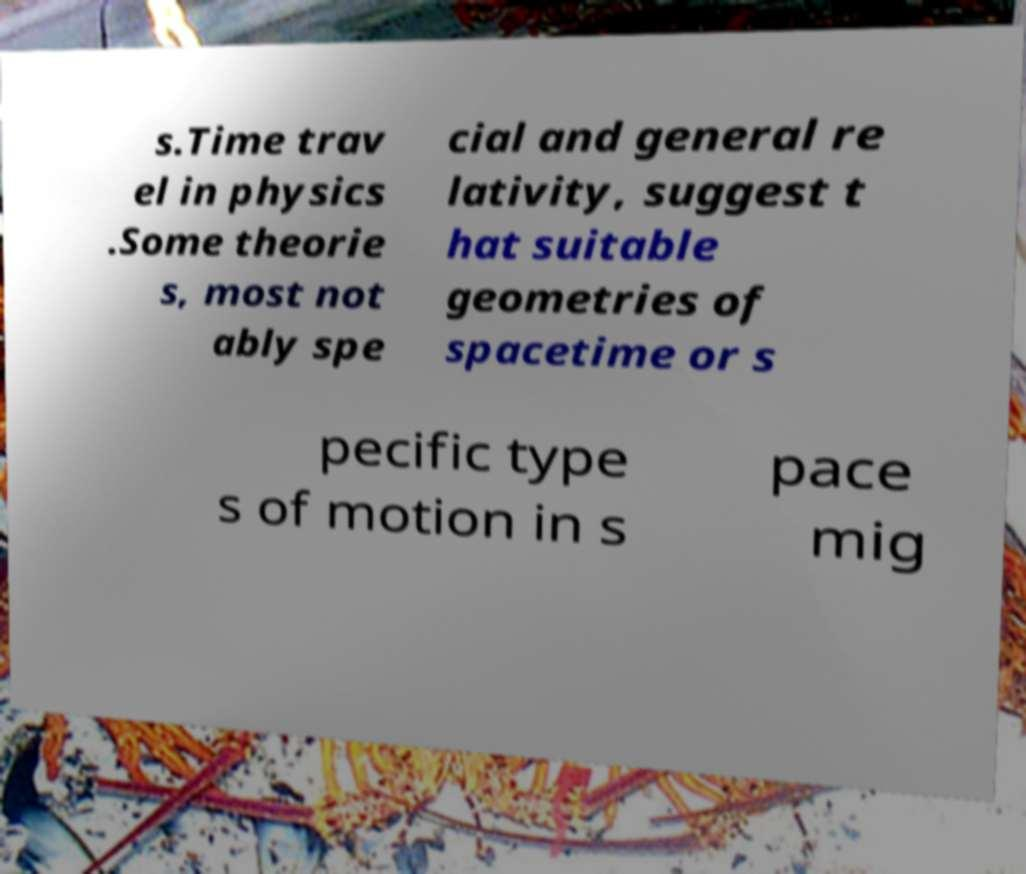What messages or text are displayed in this image? I need them in a readable, typed format. s.Time trav el in physics .Some theorie s, most not ably spe cial and general re lativity, suggest t hat suitable geometries of spacetime or s pecific type s of motion in s pace mig 